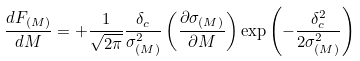Convert formula to latex. <formula><loc_0><loc_0><loc_500><loc_500>\frac { d F _ { ( M ) } } { d M } = + \frac { 1 } { \sqrt { 2 \pi } } \frac { \delta _ { c } } { \sigma _ { ( M ) } ^ { 2 } } \left ( \frac { \partial \sigma _ { ( M ) } } { \partial M } \right ) \exp \left ( - \frac { \delta _ { c } ^ { 2 } } { 2 \sigma _ { ( M ) } ^ { 2 } } \right )</formula> 